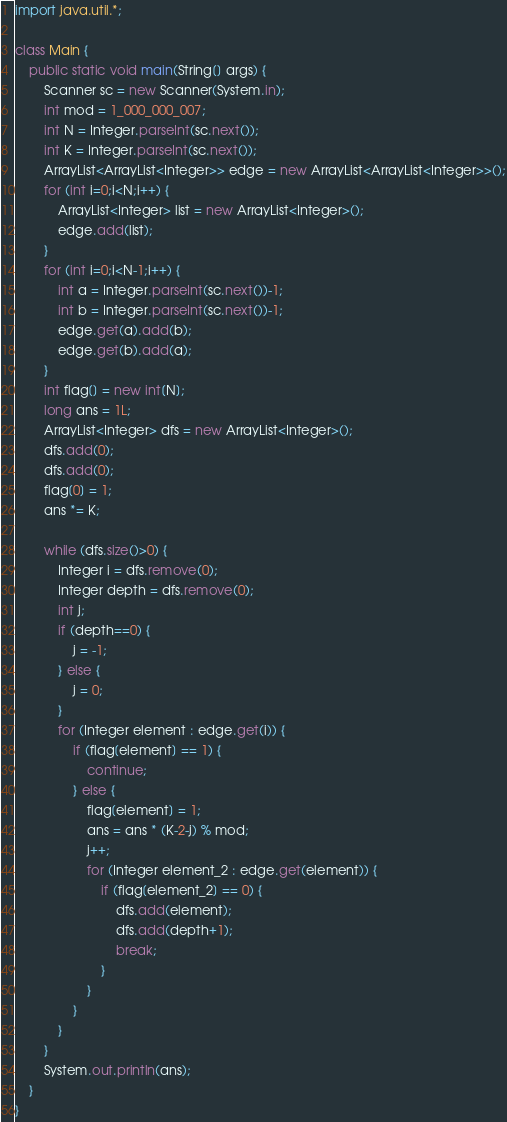<code> <loc_0><loc_0><loc_500><loc_500><_Java_>import java.util.*;

class Main {
	public static void main(String[] args) {
		Scanner sc = new Scanner(System.in);
		int mod = 1_000_000_007;
		int N = Integer.parseInt(sc.next());
		int K = Integer.parseInt(sc.next());
		ArrayList<ArrayList<Integer>> edge = new ArrayList<ArrayList<Integer>>();
		for (int i=0;i<N;i++) {
			ArrayList<Integer> list = new ArrayList<Integer>();
			edge.add(list);
		}
		for (int i=0;i<N-1;i++) {
			int a = Integer.parseInt(sc.next())-1;
			int b = Integer.parseInt(sc.next())-1;
			edge.get(a).add(b);
			edge.get(b).add(a);
		}
		int flag[] = new int[N];
		long ans = 1L;
		ArrayList<Integer> dfs = new ArrayList<Integer>();
		dfs.add(0);
		dfs.add(0);
		flag[0] = 1;
		ans *= K;

		while (dfs.size()>0) {
			Integer i = dfs.remove(0);
			Integer depth = dfs.remove(0);
			int j;
			if (depth==0) {
				j = -1;
			} else {
				j = 0;
			}
			for (Integer element : edge.get(i)) {
				if (flag[element] == 1) {
					continue;
				} else {
					flag[element] = 1;
					ans = ans * (K-2-j) % mod;
					j++;
					for (Integer element_2 : edge.get(element)) {
						if (flag[element_2] == 0) {
							dfs.add(element);
							dfs.add(depth+1);
							break;
						}
					}
				}
			}
		}
		System.out.println(ans);
	}
}</code> 